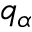Convert formula to latex. <formula><loc_0><loc_0><loc_500><loc_500>q _ { \alpha }</formula> 